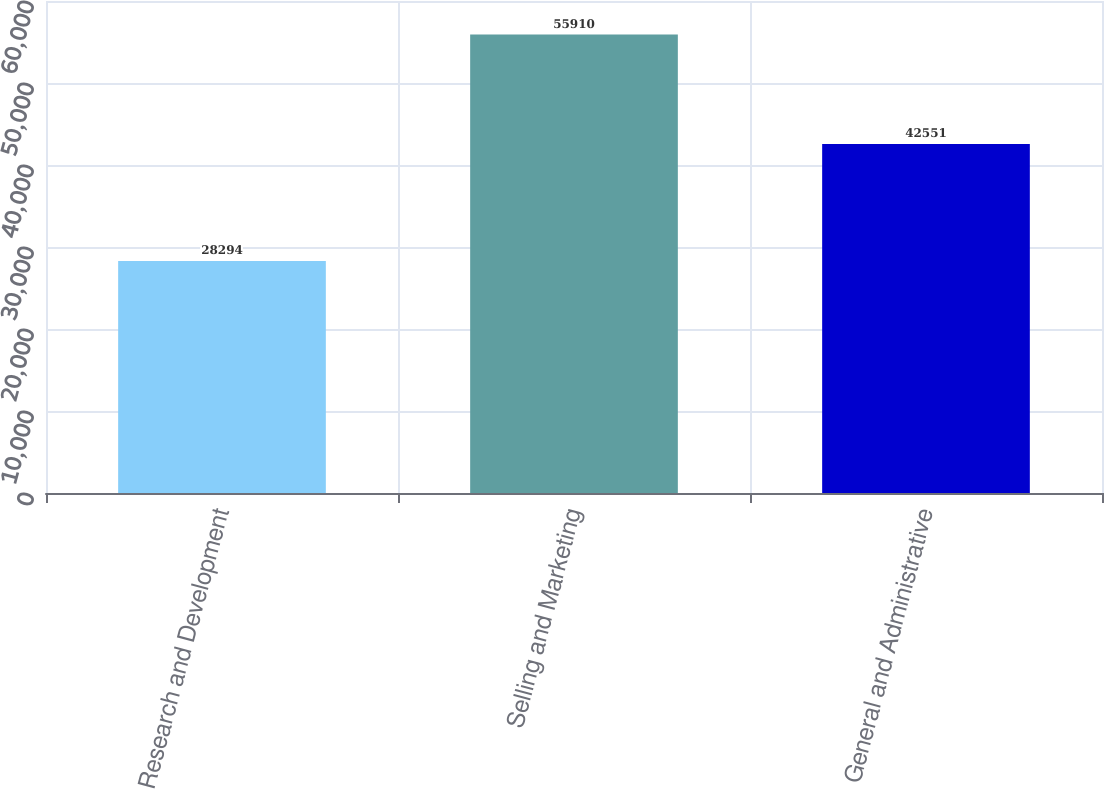<chart> <loc_0><loc_0><loc_500><loc_500><bar_chart><fcel>Research and Development<fcel>Selling and Marketing<fcel>General and Administrative<nl><fcel>28294<fcel>55910<fcel>42551<nl></chart> 